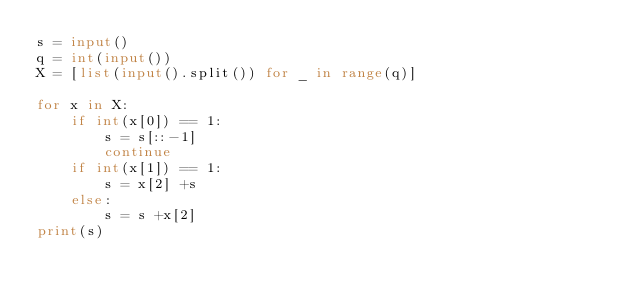<code> <loc_0><loc_0><loc_500><loc_500><_Python_>s = input()
q = int(input())
X = [list(input().split()) for _ in range(q)]

for x in X:
    if int(x[0]) == 1:
        s = s[::-1]
        continue
    if int(x[1]) == 1:
        s = x[2] +s
    else:
        s = s +x[2]
print(s)</code> 